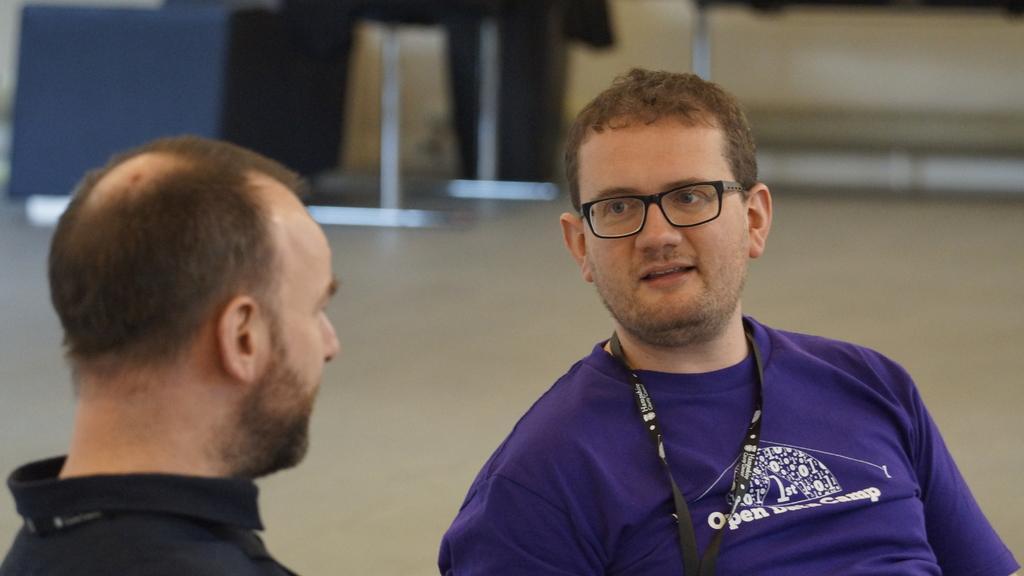Could you give a brief overview of what you see in this image? In this picture we can observe two men. Both of them are wearing black color tags in their necks. One of them is wearing spectacles and a violet color T shirt. In the background we can observe floor. 